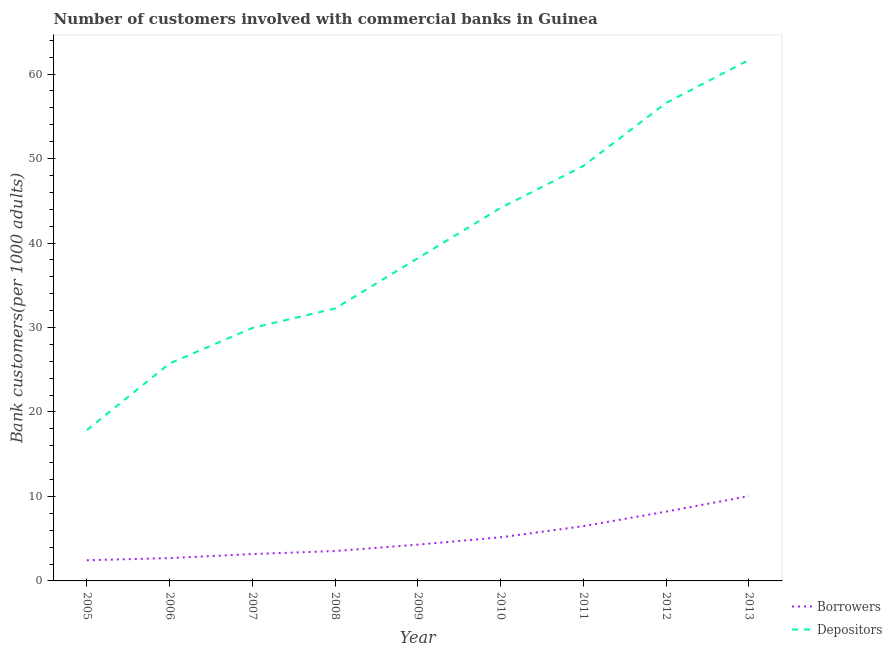How many different coloured lines are there?
Your response must be concise. 2. Does the line corresponding to number of borrowers intersect with the line corresponding to number of depositors?
Make the answer very short. No. What is the number of borrowers in 2010?
Provide a succinct answer. 5.16. Across all years, what is the maximum number of depositors?
Ensure brevity in your answer.  61.68. Across all years, what is the minimum number of depositors?
Your answer should be very brief. 17.85. In which year was the number of depositors maximum?
Ensure brevity in your answer.  2013. What is the total number of borrowers in the graph?
Offer a very short reply. 46.06. What is the difference between the number of depositors in 2005 and that in 2009?
Offer a very short reply. -20.36. What is the difference between the number of depositors in 2011 and the number of borrowers in 2005?
Your response must be concise. 46.68. What is the average number of depositors per year?
Your response must be concise. 39.51. In the year 2013, what is the difference between the number of depositors and number of borrowers?
Offer a very short reply. 51.64. What is the ratio of the number of borrowers in 2007 to that in 2011?
Your answer should be very brief. 0.49. Is the difference between the number of borrowers in 2010 and 2011 greater than the difference between the number of depositors in 2010 and 2011?
Offer a very short reply. Yes. What is the difference between the highest and the second highest number of borrowers?
Your answer should be compact. 1.84. What is the difference between the highest and the lowest number of depositors?
Keep it short and to the point. 43.83. In how many years, is the number of borrowers greater than the average number of borrowers taken over all years?
Keep it short and to the point. 4. Is the number of depositors strictly greater than the number of borrowers over the years?
Provide a short and direct response. Yes. Does the graph contain grids?
Provide a succinct answer. No. How many legend labels are there?
Offer a very short reply. 2. What is the title of the graph?
Keep it short and to the point. Number of customers involved with commercial banks in Guinea. What is the label or title of the X-axis?
Offer a terse response. Year. What is the label or title of the Y-axis?
Offer a terse response. Bank customers(per 1000 adults). What is the Bank customers(per 1000 adults) in Borrowers in 2005?
Provide a short and direct response. 2.45. What is the Bank customers(per 1000 adults) in Depositors in 2005?
Your response must be concise. 17.85. What is the Bank customers(per 1000 adults) in Borrowers in 2006?
Your answer should be compact. 2.7. What is the Bank customers(per 1000 adults) of Depositors in 2006?
Give a very brief answer. 25.74. What is the Bank customers(per 1000 adults) in Borrowers in 2007?
Make the answer very short. 3.18. What is the Bank customers(per 1000 adults) of Depositors in 2007?
Make the answer very short. 29.95. What is the Bank customers(per 1000 adults) of Borrowers in 2008?
Ensure brevity in your answer.  3.54. What is the Bank customers(per 1000 adults) in Depositors in 2008?
Give a very brief answer. 32.26. What is the Bank customers(per 1000 adults) of Borrowers in 2009?
Give a very brief answer. 4.3. What is the Bank customers(per 1000 adults) in Depositors in 2009?
Ensure brevity in your answer.  38.21. What is the Bank customers(per 1000 adults) in Borrowers in 2010?
Offer a very short reply. 5.16. What is the Bank customers(per 1000 adults) in Depositors in 2010?
Give a very brief answer. 44.16. What is the Bank customers(per 1000 adults) of Borrowers in 2011?
Offer a terse response. 6.48. What is the Bank customers(per 1000 adults) in Depositors in 2011?
Keep it short and to the point. 49.12. What is the Bank customers(per 1000 adults) in Borrowers in 2012?
Offer a terse response. 8.2. What is the Bank customers(per 1000 adults) in Depositors in 2012?
Give a very brief answer. 56.59. What is the Bank customers(per 1000 adults) of Borrowers in 2013?
Ensure brevity in your answer.  10.05. What is the Bank customers(per 1000 adults) of Depositors in 2013?
Provide a succinct answer. 61.68. Across all years, what is the maximum Bank customers(per 1000 adults) in Borrowers?
Your answer should be very brief. 10.05. Across all years, what is the maximum Bank customers(per 1000 adults) of Depositors?
Ensure brevity in your answer.  61.68. Across all years, what is the minimum Bank customers(per 1000 adults) in Borrowers?
Your answer should be compact. 2.45. Across all years, what is the minimum Bank customers(per 1000 adults) of Depositors?
Your response must be concise. 17.85. What is the total Bank customers(per 1000 adults) in Borrowers in the graph?
Make the answer very short. 46.06. What is the total Bank customers(per 1000 adults) in Depositors in the graph?
Provide a succinct answer. 355.56. What is the difference between the Bank customers(per 1000 adults) in Borrowers in 2005 and that in 2006?
Your answer should be compact. -0.25. What is the difference between the Bank customers(per 1000 adults) in Depositors in 2005 and that in 2006?
Offer a terse response. -7.89. What is the difference between the Bank customers(per 1000 adults) of Borrowers in 2005 and that in 2007?
Keep it short and to the point. -0.73. What is the difference between the Bank customers(per 1000 adults) of Depositors in 2005 and that in 2007?
Your response must be concise. -12.09. What is the difference between the Bank customers(per 1000 adults) of Borrowers in 2005 and that in 2008?
Ensure brevity in your answer.  -1.09. What is the difference between the Bank customers(per 1000 adults) of Depositors in 2005 and that in 2008?
Your response must be concise. -14.4. What is the difference between the Bank customers(per 1000 adults) of Borrowers in 2005 and that in 2009?
Ensure brevity in your answer.  -1.85. What is the difference between the Bank customers(per 1000 adults) of Depositors in 2005 and that in 2009?
Make the answer very short. -20.36. What is the difference between the Bank customers(per 1000 adults) of Borrowers in 2005 and that in 2010?
Offer a terse response. -2.72. What is the difference between the Bank customers(per 1000 adults) of Depositors in 2005 and that in 2010?
Your answer should be compact. -26.3. What is the difference between the Bank customers(per 1000 adults) of Borrowers in 2005 and that in 2011?
Keep it short and to the point. -4.04. What is the difference between the Bank customers(per 1000 adults) of Depositors in 2005 and that in 2011?
Keep it short and to the point. -31.27. What is the difference between the Bank customers(per 1000 adults) of Borrowers in 2005 and that in 2012?
Provide a short and direct response. -5.76. What is the difference between the Bank customers(per 1000 adults) of Depositors in 2005 and that in 2012?
Provide a succinct answer. -38.74. What is the difference between the Bank customers(per 1000 adults) in Borrowers in 2005 and that in 2013?
Keep it short and to the point. -7.6. What is the difference between the Bank customers(per 1000 adults) of Depositors in 2005 and that in 2013?
Make the answer very short. -43.83. What is the difference between the Bank customers(per 1000 adults) of Borrowers in 2006 and that in 2007?
Offer a very short reply. -0.48. What is the difference between the Bank customers(per 1000 adults) in Depositors in 2006 and that in 2007?
Give a very brief answer. -4.2. What is the difference between the Bank customers(per 1000 adults) in Borrowers in 2006 and that in 2008?
Ensure brevity in your answer.  -0.84. What is the difference between the Bank customers(per 1000 adults) in Depositors in 2006 and that in 2008?
Provide a short and direct response. -6.51. What is the difference between the Bank customers(per 1000 adults) of Borrowers in 2006 and that in 2009?
Keep it short and to the point. -1.59. What is the difference between the Bank customers(per 1000 adults) in Depositors in 2006 and that in 2009?
Your answer should be compact. -12.47. What is the difference between the Bank customers(per 1000 adults) in Borrowers in 2006 and that in 2010?
Keep it short and to the point. -2.46. What is the difference between the Bank customers(per 1000 adults) of Depositors in 2006 and that in 2010?
Give a very brief answer. -18.41. What is the difference between the Bank customers(per 1000 adults) in Borrowers in 2006 and that in 2011?
Your response must be concise. -3.78. What is the difference between the Bank customers(per 1000 adults) in Depositors in 2006 and that in 2011?
Make the answer very short. -23.38. What is the difference between the Bank customers(per 1000 adults) in Borrowers in 2006 and that in 2012?
Keep it short and to the point. -5.5. What is the difference between the Bank customers(per 1000 adults) of Depositors in 2006 and that in 2012?
Ensure brevity in your answer.  -30.85. What is the difference between the Bank customers(per 1000 adults) in Borrowers in 2006 and that in 2013?
Provide a short and direct response. -7.34. What is the difference between the Bank customers(per 1000 adults) in Depositors in 2006 and that in 2013?
Offer a terse response. -35.94. What is the difference between the Bank customers(per 1000 adults) in Borrowers in 2007 and that in 2008?
Give a very brief answer. -0.36. What is the difference between the Bank customers(per 1000 adults) in Depositors in 2007 and that in 2008?
Make the answer very short. -2.31. What is the difference between the Bank customers(per 1000 adults) of Borrowers in 2007 and that in 2009?
Provide a short and direct response. -1.12. What is the difference between the Bank customers(per 1000 adults) in Depositors in 2007 and that in 2009?
Offer a terse response. -8.26. What is the difference between the Bank customers(per 1000 adults) of Borrowers in 2007 and that in 2010?
Your answer should be very brief. -1.99. What is the difference between the Bank customers(per 1000 adults) in Depositors in 2007 and that in 2010?
Offer a very short reply. -14.21. What is the difference between the Bank customers(per 1000 adults) in Borrowers in 2007 and that in 2011?
Ensure brevity in your answer.  -3.31. What is the difference between the Bank customers(per 1000 adults) in Depositors in 2007 and that in 2011?
Your answer should be compact. -19.18. What is the difference between the Bank customers(per 1000 adults) of Borrowers in 2007 and that in 2012?
Your response must be concise. -5.03. What is the difference between the Bank customers(per 1000 adults) in Depositors in 2007 and that in 2012?
Provide a succinct answer. -26.64. What is the difference between the Bank customers(per 1000 adults) of Borrowers in 2007 and that in 2013?
Offer a very short reply. -6.87. What is the difference between the Bank customers(per 1000 adults) in Depositors in 2007 and that in 2013?
Provide a succinct answer. -31.74. What is the difference between the Bank customers(per 1000 adults) of Borrowers in 2008 and that in 2009?
Offer a very short reply. -0.76. What is the difference between the Bank customers(per 1000 adults) in Depositors in 2008 and that in 2009?
Offer a very short reply. -5.95. What is the difference between the Bank customers(per 1000 adults) in Borrowers in 2008 and that in 2010?
Offer a very short reply. -1.63. What is the difference between the Bank customers(per 1000 adults) of Depositors in 2008 and that in 2010?
Keep it short and to the point. -11.9. What is the difference between the Bank customers(per 1000 adults) in Borrowers in 2008 and that in 2011?
Offer a very short reply. -2.94. What is the difference between the Bank customers(per 1000 adults) of Depositors in 2008 and that in 2011?
Your answer should be compact. -16.87. What is the difference between the Bank customers(per 1000 adults) of Borrowers in 2008 and that in 2012?
Your answer should be very brief. -4.67. What is the difference between the Bank customers(per 1000 adults) in Depositors in 2008 and that in 2012?
Keep it short and to the point. -24.33. What is the difference between the Bank customers(per 1000 adults) of Borrowers in 2008 and that in 2013?
Ensure brevity in your answer.  -6.51. What is the difference between the Bank customers(per 1000 adults) of Depositors in 2008 and that in 2013?
Keep it short and to the point. -29.43. What is the difference between the Bank customers(per 1000 adults) of Borrowers in 2009 and that in 2010?
Offer a terse response. -0.87. What is the difference between the Bank customers(per 1000 adults) in Depositors in 2009 and that in 2010?
Offer a very short reply. -5.95. What is the difference between the Bank customers(per 1000 adults) in Borrowers in 2009 and that in 2011?
Your response must be concise. -2.19. What is the difference between the Bank customers(per 1000 adults) of Depositors in 2009 and that in 2011?
Keep it short and to the point. -10.92. What is the difference between the Bank customers(per 1000 adults) of Borrowers in 2009 and that in 2012?
Provide a succinct answer. -3.91. What is the difference between the Bank customers(per 1000 adults) of Depositors in 2009 and that in 2012?
Your answer should be compact. -18.38. What is the difference between the Bank customers(per 1000 adults) in Borrowers in 2009 and that in 2013?
Offer a very short reply. -5.75. What is the difference between the Bank customers(per 1000 adults) of Depositors in 2009 and that in 2013?
Your answer should be very brief. -23.47. What is the difference between the Bank customers(per 1000 adults) of Borrowers in 2010 and that in 2011?
Your answer should be compact. -1.32. What is the difference between the Bank customers(per 1000 adults) in Depositors in 2010 and that in 2011?
Provide a short and direct response. -4.97. What is the difference between the Bank customers(per 1000 adults) of Borrowers in 2010 and that in 2012?
Ensure brevity in your answer.  -3.04. What is the difference between the Bank customers(per 1000 adults) of Depositors in 2010 and that in 2012?
Make the answer very short. -12.44. What is the difference between the Bank customers(per 1000 adults) of Borrowers in 2010 and that in 2013?
Ensure brevity in your answer.  -4.88. What is the difference between the Bank customers(per 1000 adults) in Depositors in 2010 and that in 2013?
Make the answer very short. -17.53. What is the difference between the Bank customers(per 1000 adults) of Borrowers in 2011 and that in 2012?
Your response must be concise. -1.72. What is the difference between the Bank customers(per 1000 adults) in Depositors in 2011 and that in 2012?
Provide a short and direct response. -7.47. What is the difference between the Bank customers(per 1000 adults) in Borrowers in 2011 and that in 2013?
Offer a terse response. -3.56. What is the difference between the Bank customers(per 1000 adults) of Depositors in 2011 and that in 2013?
Ensure brevity in your answer.  -12.56. What is the difference between the Bank customers(per 1000 adults) of Borrowers in 2012 and that in 2013?
Make the answer very short. -1.84. What is the difference between the Bank customers(per 1000 adults) in Depositors in 2012 and that in 2013?
Make the answer very short. -5.09. What is the difference between the Bank customers(per 1000 adults) of Borrowers in 2005 and the Bank customers(per 1000 adults) of Depositors in 2006?
Offer a terse response. -23.29. What is the difference between the Bank customers(per 1000 adults) of Borrowers in 2005 and the Bank customers(per 1000 adults) of Depositors in 2007?
Provide a succinct answer. -27.5. What is the difference between the Bank customers(per 1000 adults) in Borrowers in 2005 and the Bank customers(per 1000 adults) in Depositors in 2008?
Offer a terse response. -29.81. What is the difference between the Bank customers(per 1000 adults) in Borrowers in 2005 and the Bank customers(per 1000 adults) in Depositors in 2009?
Your answer should be very brief. -35.76. What is the difference between the Bank customers(per 1000 adults) in Borrowers in 2005 and the Bank customers(per 1000 adults) in Depositors in 2010?
Your response must be concise. -41.71. What is the difference between the Bank customers(per 1000 adults) of Borrowers in 2005 and the Bank customers(per 1000 adults) of Depositors in 2011?
Give a very brief answer. -46.68. What is the difference between the Bank customers(per 1000 adults) of Borrowers in 2005 and the Bank customers(per 1000 adults) of Depositors in 2012?
Provide a short and direct response. -54.14. What is the difference between the Bank customers(per 1000 adults) in Borrowers in 2005 and the Bank customers(per 1000 adults) in Depositors in 2013?
Your answer should be compact. -59.23. What is the difference between the Bank customers(per 1000 adults) of Borrowers in 2006 and the Bank customers(per 1000 adults) of Depositors in 2007?
Your response must be concise. -27.24. What is the difference between the Bank customers(per 1000 adults) of Borrowers in 2006 and the Bank customers(per 1000 adults) of Depositors in 2008?
Ensure brevity in your answer.  -29.55. What is the difference between the Bank customers(per 1000 adults) in Borrowers in 2006 and the Bank customers(per 1000 adults) in Depositors in 2009?
Offer a terse response. -35.51. What is the difference between the Bank customers(per 1000 adults) in Borrowers in 2006 and the Bank customers(per 1000 adults) in Depositors in 2010?
Make the answer very short. -41.45. What is the difference between the Bank customers(per 1000 adults) in Borrowers in 2006 and the Bank customers(per 1000 adults) in Depositors in 2011?
Keep it short and to the point. -46.42. What is the difference between the Bank customers(per 1000 adults) of Borrowers in 2006 and the Bank customers(per 1000 adults) of Depositors in 2012?
Provide a short and direct response. -53.89. What is the difference between the Bank customers(per 1000 adults) in Borrowers in 2006 and the Bank customers(per 1000 adults) in Depositors in 2013?
Your response must be concise. -58.98. What is the difference between the Bank customers(per 1000 adults) of Borrowers in 2007 and the Bank customers(per 1000 adults) of Depositors in 2008?
Offer a terse response. -29.08. What is the difference between the Bank customers(per 1000 adults) in Borrowers in 2007 and the Bank customers(per 1000 adults) in Depositors in 2009?
Give a very brief answer. -35.03. What is the difference between the Bank customers(per 1000 adults) of Borrowers in 2007 and the Bank customers(per 1000 adults) of Depositors in 2010?
Offer a terse response. -40.98. What is the difference between the Bank customers(per 1000 adults) of Borrowers in 2007 and the Bank customers(per 1000 adults) of Depositors in 2011?
Your answer should be compact. -45.95. What is the difference between the Bank customers(per 1000 adults) of Borrowers in 2007 and the Bank customers(per 1000 adults) of Depositors in 2012?
Provide a short and direct response. -53.41. What is the difference between the Bank customers(per 1000 adults) of Borrowers in 2007 and the Bank customers(per 1000 adults) of Depositors in 2013?
Make the answer very short. -58.5. What is the difference between the Bank customers(per 1000 adults) in Borrowers in 2008 and the Bank customers(per 1000 adults) in Depositors in 2009?
Your answer should be compact. -34.67. What is the difference between the Bank customers(per 1000 adults) of Borrowers in 2008 and the Bank customers(per 1000 adults) of Depositors in 2010?
Provide a short and direct response. -40.62. What is the difference between the Bank customers(per 1000 adults) of Borrowers in 2008 and the Bank customers(per 1000 adults) of Depositors in 2011?
Your response must be concise. -45.58. What is the difference between the Bank customers(per 1000 adults) of Borrowers in 2008 and the Bank customers(per 1000 adults) of Depositors in 2012?
Your answer should be very brief. -53.05. What is the difference between the Bank customers(per 1000 adults) in Borrowers in 2008 and the Bank customers(per 1000 adults) in Depositors in 2013?
Provide a succinct answer. -58.14. What is the difference between the Bank customers(per 1000 adults) in Borrowers in 2009 and the Bank customers(per 1000 adults) in Depositors in 2010?
Keep it short and to the point. -39.86. What is the difference between the Bank customers(per 1000 adults) of Borrowers in 2009 and the Bank customers(per 1000 adults) of Depositors in 2011?
Provide a short and direct response. -44.83. What is the difference between the Bank customers(per 1000 adults) of Borrowers in 2009 and the Bank customers(per 1000 adults) of Depositors in 2012?
Offer a terse response. -52.29. What is the difference between the Bank customers(per 1000 adults) in Borrowers in 2009 and the Bank customers(per 1000 adults) in Depositors in 2013?
Make the answer very short. -57.39. What is the difference between the Bank customers(per 1000 adults) of Borrowers in 2010 and the Bank customers(per 1000 adults) of Depositors in 2011?
Offer a terse response. -43.96. What is the difference between the Bank customers(per 1000 adults) in Borrowers in 2010 and the Bank customers(per 1000 adults) in Depositors in 2012?
Make the answer very short. -51.43. What is the difference between the Bank customers(per 1000 adults) in Borrowers in 2010 and the Bank customers(per 1000 adults) in Depositors in 2013?
Provide a succinct answer. -56.52. What is the difference between the Bank customers(per 1000 adults) of Borrowers in 2011 and the Bank customers(per 1000 adults) of Depositors in 2012?
Offer a terse response. -50.11. What is the difference between the Bank customers(per 1000 adults) of Borrowers in 2011 and the Bank customers(per 1000 adults) of Depositors in 2013?
Keep it short and to the point. -55.2. What is the difference between the Bank customers(per 1000 adults) of Borrowers in 2012 and the Bank customers(per 1000 adults) of Depositors in 2013?
Ensure brevity in your answer.  -53.48. What is the average Bank customers(per 1000 adults) in Borrowers per year?
Make the answer very short. 5.12. What is the average Bank customers(per 1000 adults) in Depositors per year?
Your response must be concise. 39.51. In the year 2005, what is the difference between the Bank customers(per 1000 adults) of Borrowers and Bank customers(per 1000 adults) of Depositors?
Your answer should be very brief. -15.4. In the year 2006, what is the difference between the Bank customers(per 1000 adults) in Borrowers and Bank customers(per 1000 adults) in Depositors?
Your answer should be very brief. -23.04. In the year 2007, what is the difference between the Bank customers(per 1000 adults) in Borrowers and Bank customers(per 1000 adults) in Depositors?
Make the answer very short. -26.77. In the year 2008, what is the difference between the Bank customers(per 1000 adults) in Borrowers and Bank customers(per 1000 adults) in Depositors?
Your answer should be compact. -28.72. In the year 2009, what is the difference between the Bank customers(per 1000 adults) in Borrowers and Bank customers(per 1000 adults) in Depositors?
Provide a succinct answer. -33.91. In the year 2010, what is the difference between the Bank customers(per 1000 adults) in Borrowers and Bank customers(per 1000 adults) in Depositors?
Provide a short and direct response. -38.99. In the year 2011, what is the difference between the Bank customers(per 1000 adults) of Borrowers and Bank customers(per 1000 adults) of Depositors?
Offer a very short reply. -42.64. In the year 2012, what is the difference between the Bank customers(per 1000 adults) in Borrowers and Bank customers(per 1000 adults) in Depositors?
Keep it short and to the point. -48.39. In the year 2013, what is the difference between the Bank customers(per 1000 adults) of Borrowers and Bank customers(per 1000 adults) of Depositors?
Ensure brevity in your answer.  -51.64. What is the ratio of the Bank customers(per 1000 adults) of Borrowers in 2005 to that in 2006?
Give a very brief answer. 0.91. What is the ratio of the Bank customers(per 1000 adults) in Depositors in 2005 to that in 2006?
Your response must be concise. 0.69. What is the ratio of the Bank customers(per 1000 adults) in Borrowers in 2005 to that in 2007?
Your response must be concise. 0.77. What is the ratio of the Bank customers(per 1000 adults) in Depositors in 2005 to that in 2007?
Offer a very short reply. 0.6. What is the ratio of the Bank customers(per 1000 adults) in Borrowers in 2005 to that in 2008?
Ensure brevity in your answer.  0.69. What is the ratio of the Bank customers(per 1000 adults) in Depositors in 2005 to that in 2008?
Your response must be concise. 0.55. What is the ratio of the Bank customers(per 1000 adults) of Borrowers in 2005 to that in 2009?
Offer a very short reply. 0.57. What is the ratio of the Bank customers(per 1000 adults) in Depositors in 2005 to that in 2009?
Keep it short and to the point. 0.47. What is the ratio of the Bank customers(per 1000 adults) of Borrowers in 2005 to that in 2010?
Keep it short and to the point. 0.47. What is the ratio of the Bank customers(per 1000 adults) in Depositors in 2005 to that in 2010?
Your answer should be very brief. 0.4. What is the ratio of the Bank customers(per 1000 adults) of Borrowers in 2005 to that in 2011?
Offer a very short reply. 0.38. What is the ratio of the Bank customers(per 1000 adults) of Depositors in 2005 to that in 2011?
Provide a succinct answer. 0.36. What is the ratio of the Bank customers(per 1000 adults) in Borrowers in 2005 to that in 2012?
Provide a succinct answer. 0.3. What is the ratio of the Bank customers(per 1000 adults) of Depositors in 2005 to that in 2012?
Offer a very short reply. 0.32. What is the ratio of the Bank customers(per 1000 adults) in Borrowers in 2005 to that in 2013?
Your answer should be compact. 0.24. What is the ratio of the Bank customers(per 1000 adults) of Depositors in 2005 to that in 2013?
Provide a succinct answer. 0.29. What is the ratio of the Bank customers(per 1000 adults) in Borrowers in 2006 to that in 2007?
Ensure brevity in your answer.  0.85. What is the ratio of the Bank customers(per 1000 adults) of Depositors in 2006 to that in 2007?
Ensure brevity in your answer.  0.86. What is the ratio of the Bank customers(per 1000 adults) in Borrowers in 2006 to that in 2008?
Keep it short and to the point. 0.76. What is the ratio of the Bank customers(per 1000 adults) in Depositors in 2006 to that in 2008?
Provide a short and direct response. 0.8. What is the ratio of the Bank customers(per 1000 adults) in Borrowers in 2006 to that in 2009?
Offer a terse response. 0.63. What is the ratio of the Bank customers(per 1000 adults) in Depositors in 2006 to that in 2009?
Your answer should be compact. 0.67. What is the ratio of the Bank customers(per 1000 adults) of Borrowers in 2006 to that in 2010?
Keep it short and to the point. 0.52. What is the ratio of the Bank customers(per 1000 adults) in Depositors in 2006 to that in 2010?
Your response must be concise. 0.58. What is the ratio of the Bank customers(per 1000 adults) of Borrowers in 2006 to that in 2011?
Provide a short and direct response. 0.42. What is the ratio of the Bank customers(per 1000 adults) of Depositors in 2006 to that in 2011?
Keep it short and to the point. 0.52. What is the ratio of the Bank customers(per 1000 adults) of Borrowers in 2006 to that in 2012?
Offer a very short reply. 0.33. What is the ratio of the Bank customers(per 1000 adults) of Depositors in 2006 to that in 2012?
Your answer should be very brief. 0.45. What is the ratio of the Bank customers(per 1000 adults) of Borrowers in 2006 to that in 2013?
Ensure brevity in your answer.  0.27. What is the ratio of the Bank customers(per 1000 adults) of Depositors in 2006 to that in 2013?
Give a very brief answer. 0.42. What is the ratio of the Bank customers(per 1000 adults) of Borrowers in 2007 to that in 2008?
Make the answer very short. 0.9. What is the ratio of the Bank customers(per 1000 adults) in Depositors in 2007 to that in 2008?
Give a very brief answer. 0.93. What is the ratio of the Bank customers(per 1000 adults) in Borrowers in 2007 to that in 2009?
Make the answer very short. 0.74. What is the ratio of the Bank customers(per 1000 adults) in Depositors in 2007 to that in 2009?
Provide a succinct answer. 0.78. What is the ratio of the Bank customers(per 1000 adults) of Borrowers in 2007 to that in 2010?
Your answer should be compact. 0.62. What is the ratio of the Bank customers(per 1000 adults) of Depositors in 2007 to that in 2010?
Your answer should be very brief. 0.68. What is the ratio of the Bank customers(per 1000 adults) in Borrowers in 2007 to that in 2011?
Your answer should be compact. 0.49. What is the ratio of the Bank customers(per 1000 adults) in Depositors in 2007 to that in 2011?
Give a very brief answer. 0.61. What is the ratio of the Bank customers(per 1000 adults) of Borrowers in 2007 to that in 2012?
Offer a very short reply. 0.39. What is the ratio of the Bank customers(per 1000 adults) in Depositors in 2007 to that in 2012?
Give a very brief answer. 0.53. What is the ratio of the Bank customers(per 1000 adults) in Borrowers in 2007 to that in 2013?
Keep it short and to the point. 0.32. What is the ratio of the Bank customers(per 1000 adults) in Depositors in 2007 to that in 2013?
Offer a very short reply. 0.49. What is the ratio of the Bank customers(per 1000 adults) in Borrowers in 2008 to that in 2009?
Keep it short and to the point. 0.82. What is the ratio of the Bank customers(per 1000 adults) of Depositors in 2008 to that in 2009?
Make the answer very short. 0.84. What is the ratio of the Bank customers(per 1000 adults) of Borrowers in 2008 to that in 2010?
Your answer should be very brief. 0.69. What is the ratio of the Bank customers(per 1000 adults) of Depositors in 2008 to that in 2010?
Your answer should be compact. 0.73. What is the ratio of the Bank customers(per 1000 adults) of Borrowers in 2008 to that in 2011?
Make the answer very short. 0.55. What is the ratio of the Bank customers(per 1000 adults) of Depositors in 2008 to that in 2011?
Your response must be concise. 0.66. What is the ratio of the Bank customers(per 1000 adults) in Borrowers in 2008 to that in 2012?
Provide a succinct answer. 0.43. What is the ratio of the Bank customers(per 1000 adults) in Depositors in 2008 to that in 2012?
Provide a short and direct response. 0.57. What is the ratio of the Bank customers(per 1000 adults) of Borrowers in 2008 to that in 2013?
Ensure brevity in your answer.  0.35. What is the ratio of the Bank customers(per 1000 adults) of Depositors in 2008 to that in 2013?
Your answer should be very brief. 0.52. What is the ratio of the Bank customers(per 1000 adults) of Borrowers in 2009 to that in 2010?
Provide a short and direct response. 0.83. What is the ratio of the Bank customers(per 1000 adults) of Depositors in 2009 to that in 2010?
Give a very brief answer. 0.87. What is the ratio of the Bank customers(per 1000 adults) in Borrowers in 2009 to that in 2011?
Your answer should be very brief. 0.66. What is the ratio of the Bank customers(per 1000 adults) of Depositors in 2009 to that in 2011?
Provide a short and direct response. 0.78. What is the ratio of the Bank customers(per 1000 adults) in Borrowers in 2009 to that in 2012?
Your answer should be very brief. 0.52. What is the ratio of the Bank customers(per 1000 adults) in Depositors in 2009 to that in 2012?
Make the answer very short. 0.68. What is the ratio of the Bank customers(per 1000 adults) of Borrowers in 2009 to that in 2013?
Provide a short and direct response. 0.43. What is the ratio of the Bank customers(per 1000 adults) in Depositors in 2009 to that in 2013?
Your response must be concise. 0.62. What is the ratio of the Bank customers(per 1000 adults) in Borrowers in 2010 to that in 2011?
Make the answer very short. 0.8. What is the ratio of the Bank customers(per 1000 adults) of Depositors in 2010 to that in 2011?
Offer a terse response. 0.9. What is the ratio of the Bank customers(per 1000 adults) of Borrowers in 2010 to that in 2012?
Offer a very short reply. 0.63. What is the ratio of the Bank customers(per 1000 adults) in Depositors in 2010 to that in 2012?
Ensure brevity in your answer.  0.78. What is the ratio of the Bank customers(per 1000 adults) in Borrowers in 2010 to that in 2013?
Make the answer very short. 0.51. What is the ratio of the Bank customers(per 1000 adults) in Depositors in 2010 to that in 2013?
Provide a short and direct response. 0.72. What is the ratio of the Bank customers(per 1000 adults) in Borrowers in 2011 to that in 2012?
Give a very brief answer. 0.79. What is the ratio of the Bank customers(per 1000 adults) in Depositors in 2011 to that in 2012?
Offer a very short reply. 0.87. What is the ratio of the Bank customers(per 1000 adults) of Borrowers in 2011 to that in 2013?
Your answer should be very brief. 0.65. What is the ratio of the Bank customers(per 1000 adults) of Depositors in 2011 to that in 2013?
Your answer should be compact. 0.8. What is the ratio of the Bank customers(per 1000 adults) in Borrowers in 2012 to that in 2013?
Offer a terse response. 0.82. What is the ratio of the Bank customers(per 1000 adults) of Depositors in 2012 to that in 2013?
Keep it short and to the point. 0.92. What is the difference between the highest and the second highest Bank customers(per 1000 adults) of Borrowers?
Your answer should be compact. 1.84. What is the difference between the highest and the second highest Bank customers(per 1000 adults) in Depositors?
Provide a succinct answer. 5.09. What is the difference between the highest and the lowest Bank customers(per 1000 adults) in Borrowers?
Make the answer very short. 7.6. What is the difference between the highest and the lowest Bank customers(per 1000 adults) of Depositors?
Ensure brevity in your answer.  43.83. 